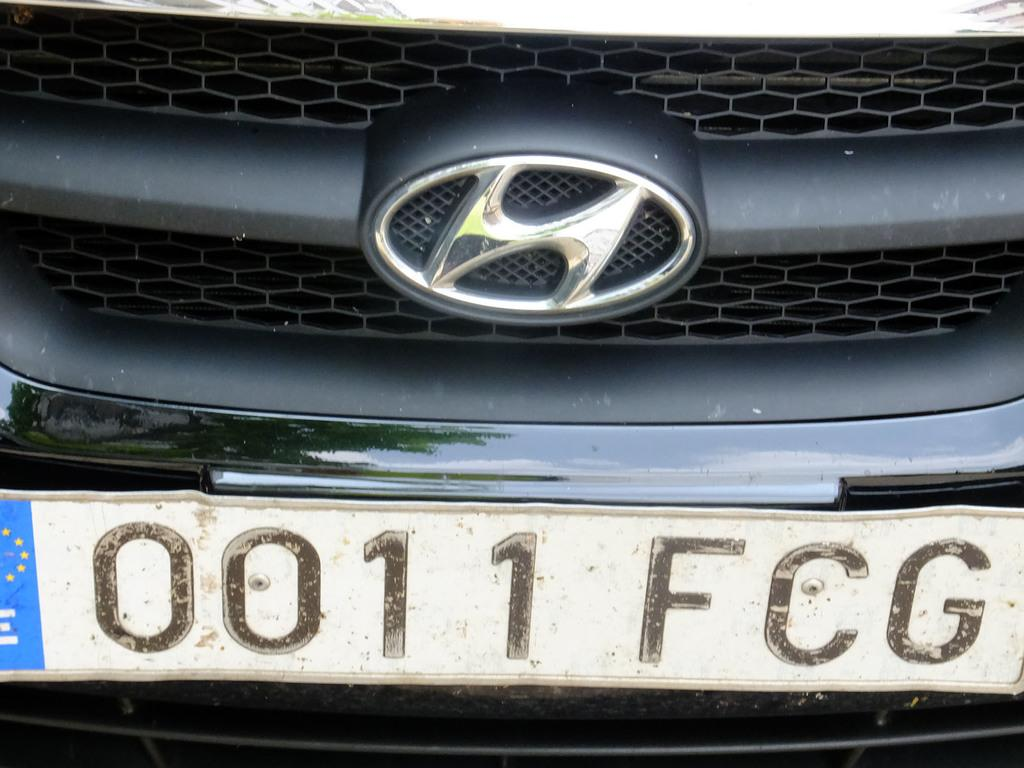<image>
Write a terse but informative summary of the picture. The front of a Hyundai vehicle with the license plate 0011FCG. 